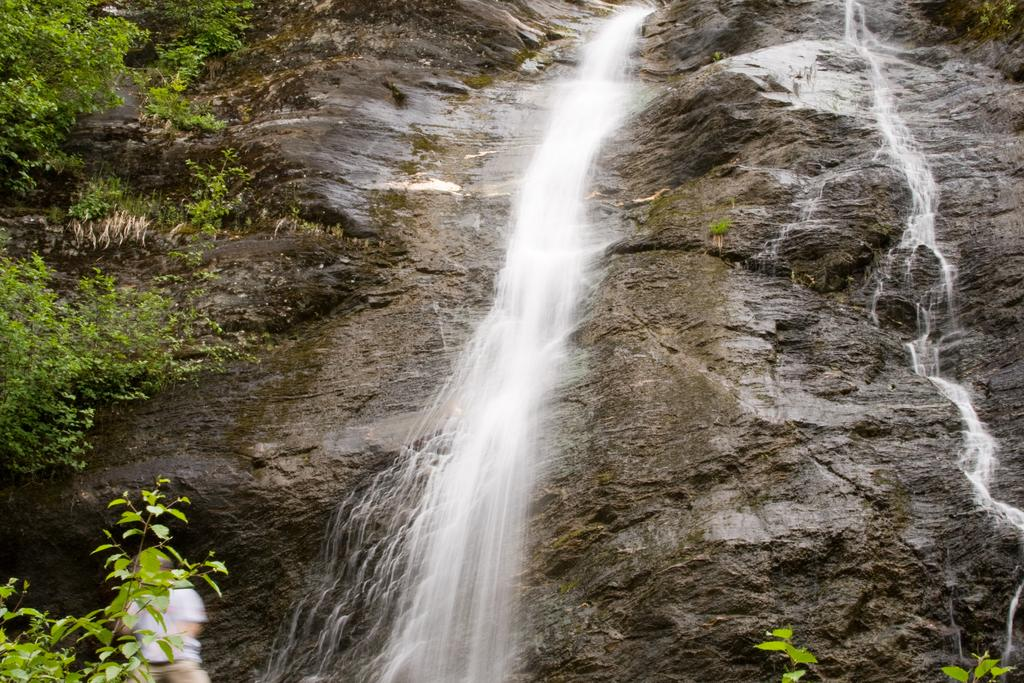What natural feature is the main subject of the image? There is a waterfall in the image. What type of vegetation can be seen on the left side of the image? There are small plants on the left side of the image. Can you describe the person in the image? There is a person at the bottom of the image. What is covering the stones in the image? There is water on the stones in the image. How many letters are visible on the waterfall in the image? There are no letters visible on the waterfall in the image. What is the duration of the minute shown in the image? There is no indication of time or duration in the image, so it is not possible to determine the length of a minute. 